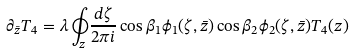Convert formula to latex. <formula><loc_0><loc_0><loc_500><loc_500>\partial _ { \bar { z } } T _ { 4 } = \lambda \oint _ { z } \frac { d \zeta } { 2 \pi i } \cos \beta _ { 1 } \phi _ { 1 } ( \zeta , \bar { z } ) \cos \beta _ { 2 } \phi _ { 2 } ( \zeta , \bar { z } ) T _ { 4 } ( z )</formula> 